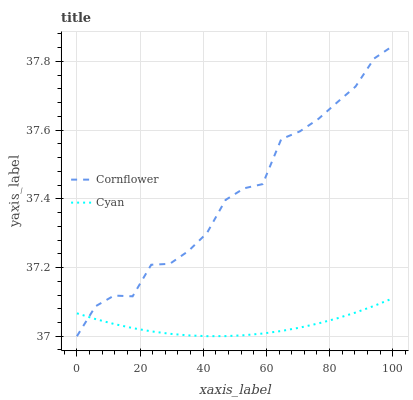Does Cyan have the minimum area under the curve?
Answer yes or no. Yes. Does Cornflower have the maximum area under the curve?
Answer yes or no. Yes. Does Cyan have the maximum area under the curve?
Answer yes or no. No. Is Cyan the smoothest?
Answer yes or no. Yes. Is Cornflower the roughest?
Answer yes or no. Yes. Is Cyan the roughest?
Answer yes or no. No. Does Cornflower have the lowest value?
Answer yes or no. Yes. Does Cyan have the lowest value?
Answer yes or no. No. Does Cornflower have the highest value?
Answer yes or no. Yes. Does Cyan have the highest value?
Answer yes or no. No. Does Cornflower intersect Cyan?
Answer yes or no. Yes. Is Cornflower less than Cyan?
Answer yes or no. No. Is Cornflower greater than Cyan?
Answer yes or no. No. 